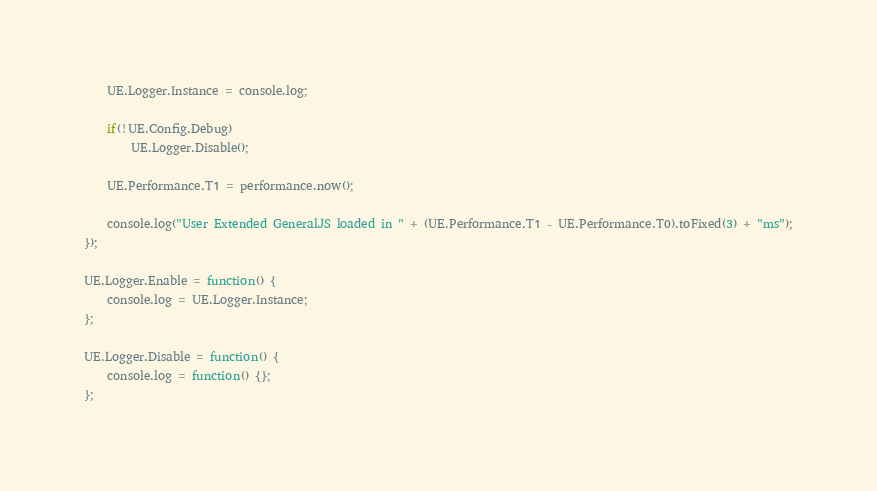Convert code to text. <code><loc_0><loc_0><loc_500><loc_500><_JavaScript_>    UE.Logger.Instance = console.log;

    if(!UE.Config.Debug)
        UE.Logger.Disable();

    UE.Performance.T1 = performance.now();

    console.log("User Extended GeneralJS loaded in " + (UE.Performance.T1 - UE.Performance.T0).toFixed(3) + "ms");
});

UE.Logger.Enable = function() {
    console.log = UE.Logger.Instance;
};

UE.Logger.Disable = function() {
    console.log = function() {};
};</code> 